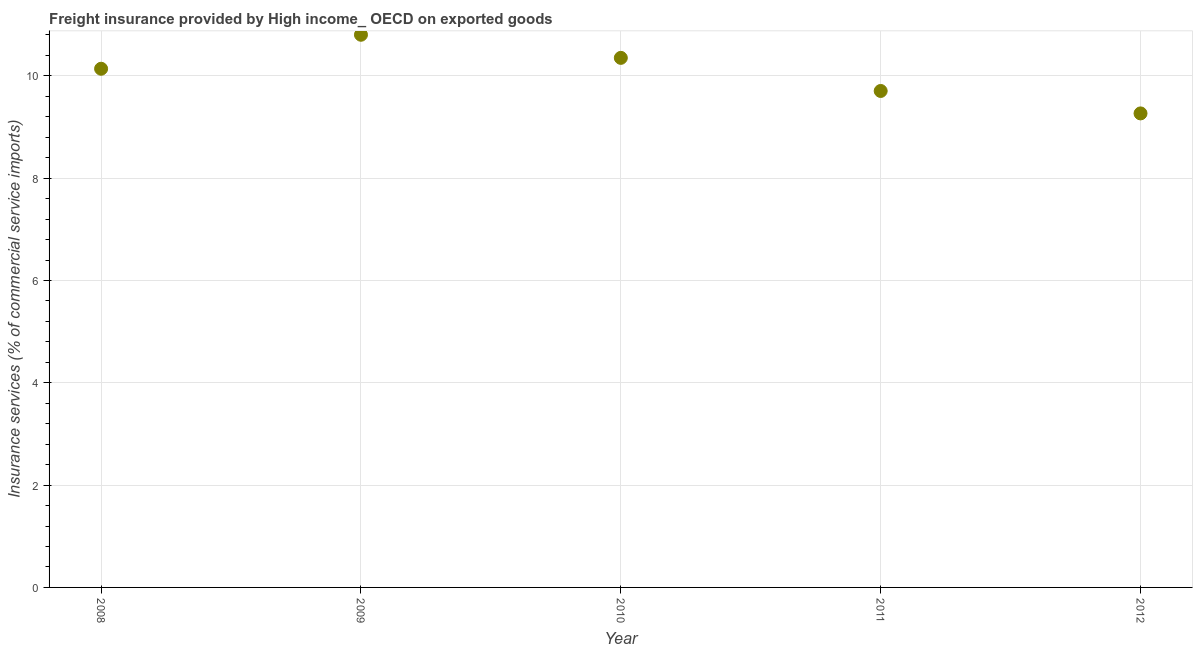What is the freight insurance in 2010?
Ensure brevity in your answer.  10.35. Across all years, what is the maximum freight insurance?
Your response must be concise. 10.8. Across all years, what is the minimum freight insurance?
Give a very brief answer. 9.27. What is the sum of the freight insurance?
Ensure brevity in your answer.  50.27. What is the difference between the freight insurance in 2008 and 2011?
Your answer should be compact. 0.43. What is the average freight insurance per year?
Offer a terse response. 10.05. What is the median freight insurance?
Offer a very short reply. 10.14. In how many years, is the freight insurance greater than 5.2 %?
Ensure brevity in your answer.  5. What is the ratio of the freight insurance in 2009 to that in 2011?
Your answer should be compact. 1.11. Is the difference between the freight insurance in 2008 and 2012 greater than the difference between any two years?
Your answer should be very brief. No. What is the difference between the highest and the second highest freight insurance?
Provide a succinct answer. 0.45. What is the difference between the highest and the lowest freight insurance?
Provide a succinct answer. 1.54. In how many years, is the freight insurance greater than the average freight insurance taken over all years?
Keep it short and to the point. 3. Does the freight insurance monotonically increase over the years?
Offer a terse response. No. How many years are there in the graph?
Your response must be concise. 5. Are the values on the major ticks of Y-axis written in scientific E-notation?
Offer a very short reply. No. Does the graph contain any zero values?
Make the answer very short. No. What is the title of the graph?
Your response must be concise. Freight insurance provided by High income_ OECD on exported goods . What is the label or title of the Y-axis?
Provide a short and direct response. Insurance services (% of commercial service imports). What is the Insurance services (% of commercial service imports) in 2008?
Give a very brief answer. 10.14. What is the Insurance services (% of commercial service imports) in 2009?
Ensure brevity in your answer.  10.8. What is the Insurance services (% of commercial service imports) in 2010?
Keep it short and to the point. 10.35. What is the Insurance services (% of commercial service imports) in 2011?
Your answer should be very brief. 9.71. What is the Insurance services (% of commercial service imports) in 2012?
Provide a succinct answer. 9.27. What is the difference between the Insurance services (% of commercial service imports) in 2008 and 2009?
Your answer should be very brief. -0.66. What is the difference between the Insurance services (% of commercial service imports) in 2008 and 2010?
Provide a succinct answer. -0.21. What is the difference between the Insurance services (% of commercial service imports) in 2008 and 2011?
Ensure brevity in your answer.  0.43. What is the difference between the Insurance services (% of commercial service imports) in 2008 and 2012?
Keep it short and to the point. 0.87. What is the difference between the Insurance services (% of commercial service imports) in 2009 and 2010?
Make the answer very short. 0.45. What is the difference between the Insurance services (% of commercial service imports) in 2009 and 2011?
Provide a succinct answer. 1.1. What is the difference between the Insurance services (% of commercial service imports) in 2009 and 2012?
Offer a terse response. 1.54. What is the difference between the Insurance services (% of commercial service imports) in 2010 and 2011?
Provide a succinct answer. 0.65. What is the difference between the Insurance services (% of commercial service imports) in 2010 and 2012?
Make the answer very short. 1.09. What is the difference between the Insurance services (% of commercial service imports) in 2011 and 2012?
Provide a short and direct response. 0.44. What is the ratio of the Insurance services (% of commercial service imports) in 2008 to that in 2009?
Your answer should be compact. 0.94. What is the ratio of the Insurance services (% of commercial service imports) in 2008 to that in 2011?
Make the answer very short. 1.04. What is the ratio of the Insurance services (% of commercial service imports) in 2008 to that in 2012?
Your response must be concise. 1.09. What is the ratio of the Insurance services (% of commercial service imports) in 2009 to that in 2010?
Ensure brevity in your answer.  1.04. What is the ratio of the Insurance services (% of commercial service imports) in 2009 to that in 2011?
Ensure brevity in your answer.  1.11. What is the ratio of the Insurance services (% of commercial service imports) in 2009 to that in 2012?
Offer a terse response. 1.17. What is the ratio of the Insurance services (% of commercial service imports) in 2010 to that in 2011?
Provide a short and direct response. 1.07. What is the ratio of the Insurance services (% of commercial service imports) in 2010 to that in 2012?
Keep it short and to the point. 1.12. What is the ratio of the Insurance services (% of commercial service imports) in 2011 to that in 2012?
Make the answer very short. 1.05. 